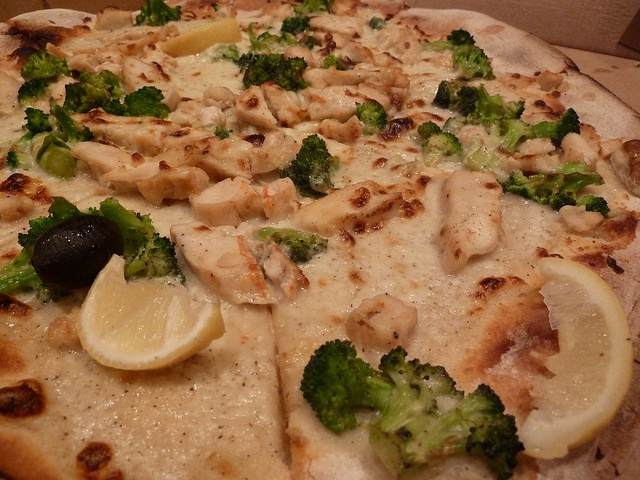Describe the objects in this image and their specific colors. I can see pizza in tan, brown, and black tones, broccoli in maroon, black, and olive tones, broccoli in maroon, black, olive, and tan tones, broccoli in maroon, olive, and black tones, and broccoli in maroon, olive, black, and tan tones in this image. 